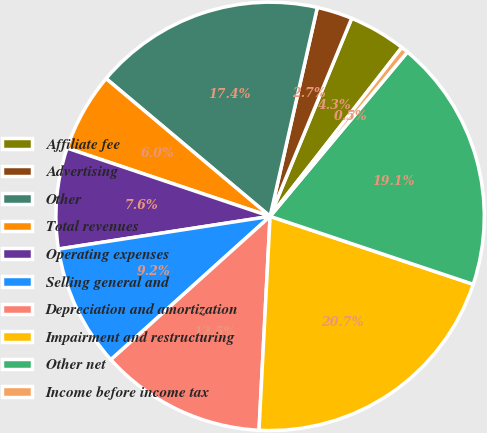<chart> <loc_0><loc_0><loc_500><loc_500><pie_chart><fcel>Affiliate fee<fcel>Advertising<fcel>Other<fcel>Total revenues<fcel>Operating expenses<fcel>Selling general and<fcel>Depreciation and amortization<fcel>Impairment and restructuring<fcel>Other net<fcel>Income before income tax<nl><fcel>4.32%<fcel>2.68%<fcel>17.42%<fcel>5.96%<fcel>7.6%<fcel>9.23%<fcel>12.51%<fcel>20.69%<fcel>19.06%<fcel>0.54%<nl></chart> 